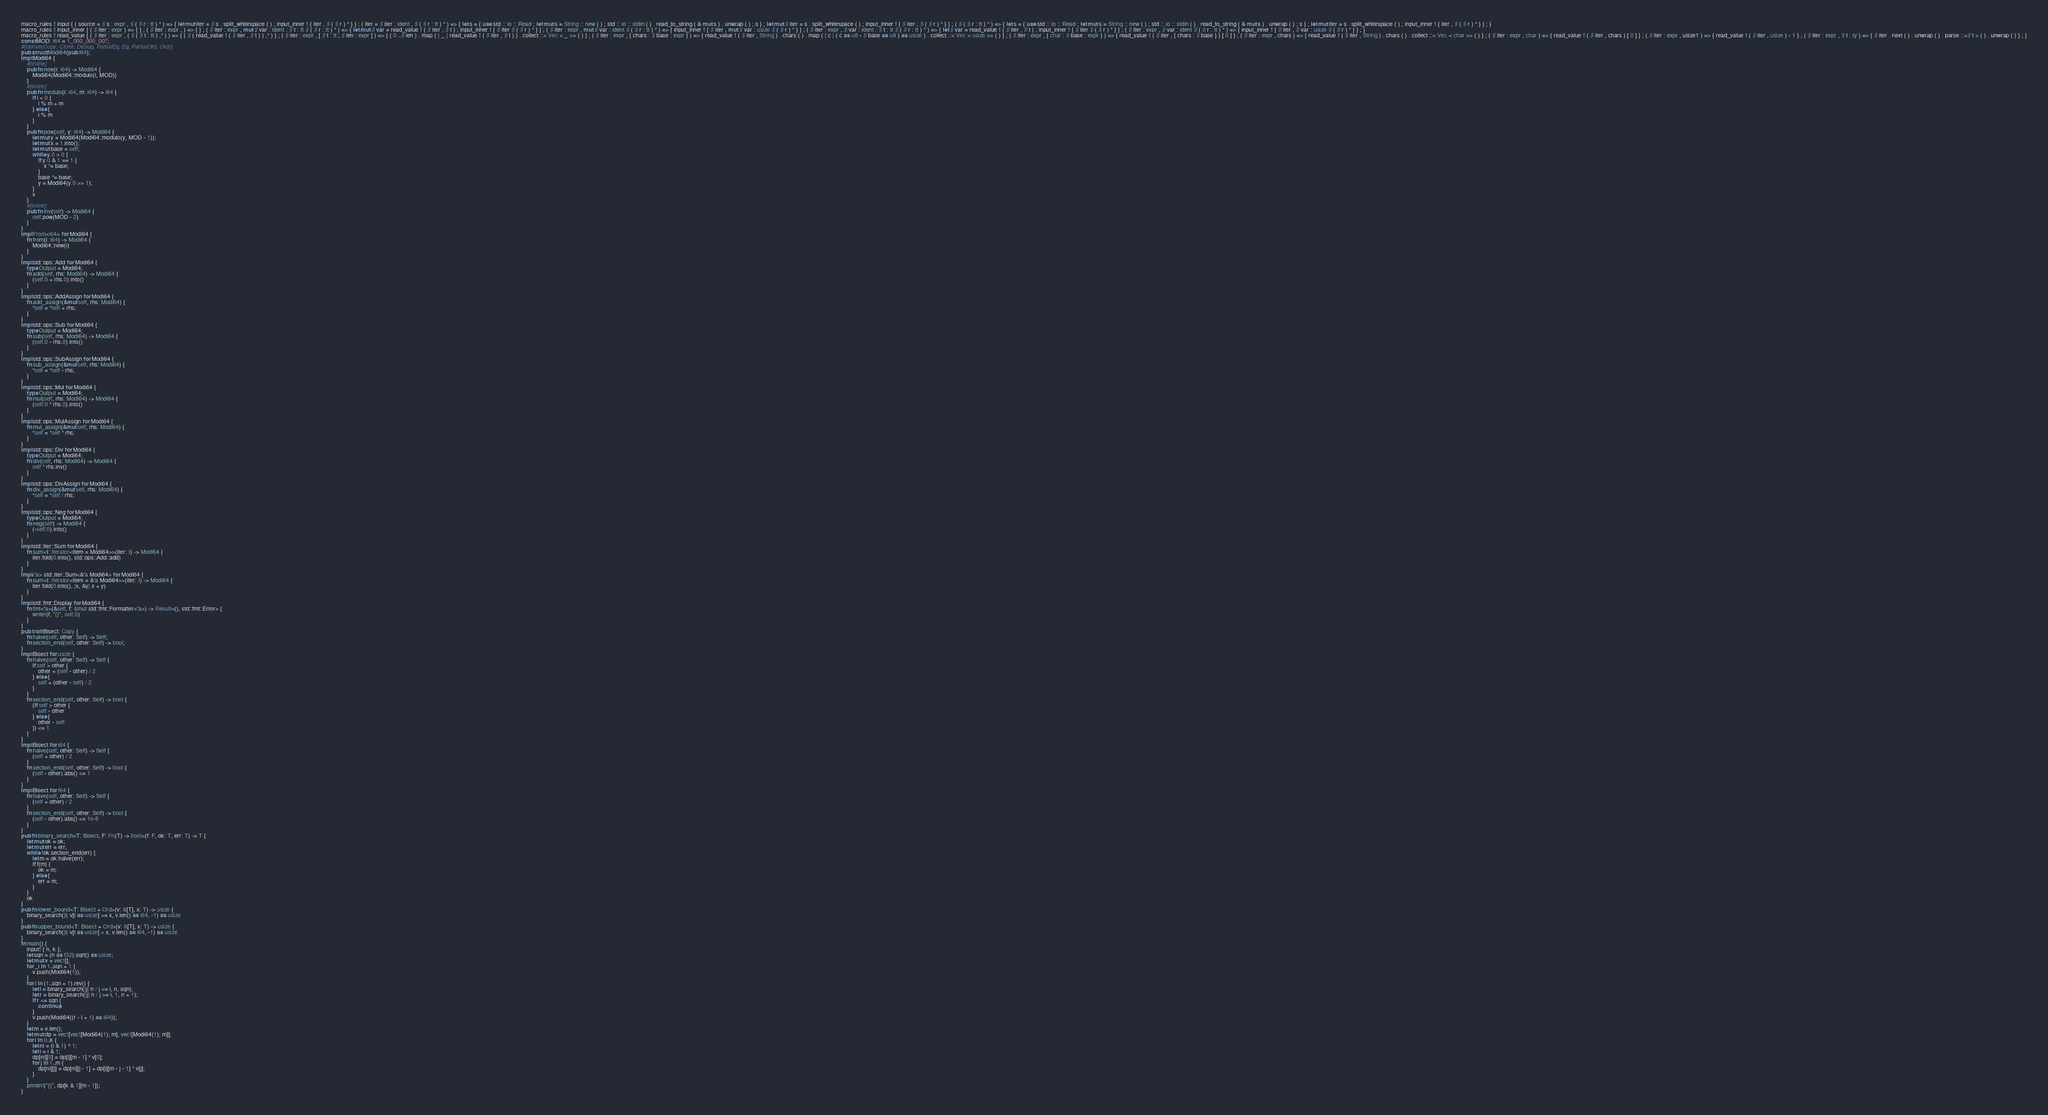Convert code to text. <code><loc_0><loc_0><loc_500><loc_500><_Rust_>macro_rules ! input { ( source = $ s : expr , $ ( $ r : tt ) * ) => { let mut iter = $ s . split_whitespace ( ) ; input_inner ! { iter , $ ( $ r ) * } } ; ( iter = $ iter : ident , $ ( $ r : tt ) * ) => { let s = { use std :: io :: Read ; let mut s = String :: new ( ) ; std :: io :: stdin ( ) . read_to_string ( & mut s ) . unwrap ( ) ; s } ; let mut $ iter = s . split_whitespace ( ) ; input_inner ! { $ iter , $ ( $ r ) * } } ; ( $ ( $ r : tt ) * ) => { let s = { use std :: io :: Read ; let mut s = String :: new ( ) ; std :: io :: stdin ( ) . read_to_string ( & mut s ) . unwrap ( ) ; s } ; let mut iter = s . split_whitespace ( ) ; input_inner ! { iter , $ ( $ r ) * } } ; }
macro_rules ! input_inner { ( $ iter : expr ) => { } ; ( $ iter : expr , ) => { } ; ( $ iter : expr , mut $ var : ident : $ t : tt $ ( $ r : tt ) * ) => { let mut $ var = read_value ! ( $ iter , $ t ) ; input_inner ! { $ iter $ ( $ r ) * } } ; ( $ iter : expr , mut $ var : ident $ ( $ r : tt ) * ) => { input_inner ! { $ iter , mut $ var : usize $ ( $ r ) * } } ; ( $ iter : expr , $ var : ident : $ t : tt $ ( $ r : tt ) * ) => { let $ var = read_value ! ( $ iter , $ t ) ; input_inner ! { $ iter $ ( $ r ) * } } ; ( $ iter : expr , $ var : ident $ ( $ r : tt ) * ) => { input_inner ! { $ iter , $ var : usize $ ( $ r ) * } } ; }
macro_rules ! read_value { ( $ iter : expr , ( $ ( $ t : tt ) ,* ) ) => { ( $ ( read_value ! ( $ iter , $ t ) ) ,* ) } ; ( $ iter : expr , [ $ t : tt ; $ len : expr ] ) => { ( 0 ..$ len ) . map ( | _ | read_value ! ( $ iter , $ t ) ) . collect ::< Vec < _ >> ( ) } ; ( $ iter : expr , { chars : $ base : expr } ) => { read_value ! ( $ iter , String ) . chars ( ) . map ( | c | ( c as u8 - $ base as u8 ) as usize ) . collect ::< Vec < usize >> ( ) } ; ( $ iter : expr , { char : $ base : expr } ) => { read_value ! ( $ iter , { chars : $ base } ) [ 0 ] } ; ( $ iter : expr , chars ) => { read_value ! ( $ iter , String ) . chars ( ) . collect ::< Vec < char >> ( ) } ; ( $ iter : expr , char ) => { read_value ! ( $ iter , chars ) [ 0 ] } ; ( $ iter : expr , usize1 ) => { read_value ! ( $ iter , usize ) - 1 } ; ( $ iter : expr , $ t : ty ) => { $ iter . next ( ) . unwrap ( ) . parse ::<$ t > ( ) . unwrap ( ) } ; }
const MOD: i64 = 1_000_000_007;
#[derive(Copy, Clone, Debug, PartialEq, Eq, PartialOrd, Ord)]
pub struct Modi64(pub i64);
impl Modi64 {
    #[inline]
    pub fn new(i: i64) -> Modi64 {
        Modi64(Modi64::modulo(i, MOD))
    }
    #[inline]
    pub fn modulo(i: i64, m: i64) -> i64 {
        if i < 0 {
            i % m + m
        } else {
            i % m
        }
    }
    pub fn pow(self, y: i64) -> Modi64 {
        let mut y = Modi64(Modi64::modulo(y, MOD - 1));
        let mut x = 1.into();
        let mut base = self;
        while y.0 > 0 {
            if y.0 & 1 == 1 {
                x *= base;
            }
            base *= base;
            y = Modi64(y.0 >> 1);
        }
        x
    }
    #[inline]
    pub fn inv(self) -> Modi64 {
        self.pow(MOD - 2)
    }
}
impl From<i64> for Modi64 {
    fn from(i: i64) -> Modi64 {
        Modi64::new(i)
    }
}
impl std::ops::Add for Modi64 {
    type Output = Modi64;
    fn add(self, rhs: Modi64) -> Modi64 {
        (self.0 + rhs.0).into()
    }
}
impl std::ops::AddAssign for Modi64 {
    fn add_assign(&mut self, rhs: Modi64) {
        *self = *self + rhs;
    }
}
impl std::ops::Sub for Modi64 {
    type Output = Modi64;
    fn sub(self, rhs: Modi64) -> Modi64 {
        (self.0 - rhs.0).into()
    }
}
impl std::ops::SubAssign for Modi64 {
    fn sub_assign(&mut self, rhs: Modi64) {
        *self = *self - rhs;
    }
}
impl std::ops::Mul for Modi64 {
    type Output = Modi64;
    fn mul(self, rhs: Modi64) -> Modi64 {
        (self.0 * rhs.0).into()
    }
}
impl std::ops::MulAssign for Modi64 {
    fn mul_assign(&mut self, rhs: Modi64) {
        *self = *self * rhs;
    }
}
impl std::ops::Div for Modi64 {
    type Output = Modi64;
    fn div(self, rhs: Modi64) -> Modi64 {
        self * rhs.inv()
    }
}
impl std::ops::DivAssign for Modi64 {
    fn div_assign(&mut self, rhs: Modi64) {
        *self = *self / rhs;
    }
}
impl std::ops::Neg for Modi64 {
    type Output = Modi64;
    fn neg(self) -> Modi64 {
        (-self.0).into()
    }
}
impl std::iter::Sum for Modi64 {
    fn sum<I: Iterator<Item = Modi64>>(iter: I) -> Modi64 {
        iter.fold(0.into(), std::ops::Add::add)
    }
}
impl<'a> std::iter::Sum<&'a Modi64> for Modi64 {
    fn sum<I: Iterator<Item = &'a Modi64>>(iter: I) -> Modi64 {
        iter.fold(0.into(), |x, &y| x + y)
    }
}
impl std::fmt::Display for Modi64 {
    fn fmt<'a>(&self, f: &mut std::fmt::Formatter<'a>) -> Result<(), std::fmt::Error> {
        write!(f, "{}", self.0)
    }
}
pub trait Bisect: Copy {
    fn halve(self, other: Self) -> Self;
    fn section_end(self, other: Self) -> bool;
}
impl Bisect for usize {
    fn halve(self, other: Self) -> Self {
        if self > other {
            other + (self - other) / 2
        } else {
            self + (other - self) / 2
        }
    }
    fn section_end(self, other: Self) -> bool {
        (if self > other {
            self - other
        } else {
            other - self
        }) <= 1
    }
}
impl Bisect for i64 {
    fn halve(self, other: Self) -> Self {
        (self + other) / 2
    }
    fn section_end(self, other: Self) -> bool {
        (self - other).abs() <= 1
    }
}
impl Bisect for f64 {
    fn halve(self, other: Self) -> Self {
        (self + other) / 2.
    }
    fn section_end(self, other: Self) -> bool {
        (self - other).abs() <= 1e-8
    }
}
pub fn binary_search<T: Bisect, F: Fn(T) -> bool>(f: F, ok: T, err: T) -> T {
    let mut ok = ok;
    let mut err = err;
    while !ok.section_end(err) {
        let m = ok.halve(err);
        if f(m) {
            ok = m;
        } else {
            err = m;
        }
    }
    ok
}
pub fn lower_bound<T: Bisect + Ord>(v: &[T], x: T) -> usize {
    binary_search(|i| v[i as usize] >= x, v.len() as i64, -1) as usize
}
pub fn upper_bound<T: Bisect + Ord>(v: &[T], x: T) -> usize {
    binary_search(|i| v[i as usize] > x, v.len() as i64, -1) as usize
}
fn main() {
    input! { n, k };
    let sqn = (n as f32).sqrt() as usize;
    let mut v = vec![];
    for _i in 1..sqn + 1 {
        v.push(Modi64(1));
    }
    for i in (1..sqn + 1).rev() {
        let l = binary_search(|j| n / j <= i, n, sqn);
        let r = binary_search(|j| n / j >= i, 1, n + 1);
        if r <= sqn {
            continue;
        }
        v.push(Modi64((r - l + 1) as i64));
    }
    let m = v.len();
    let mut dp = vec![vec![Modi64(1); m], vec![Modi64(1); m]];
    for i in 0..k {
        let ni = (i & 1) ^ 1;
        let i = i & 1;
        dp[ni][0] = dp[i][m - 1] * v[0];
        for j in 1..m {
            dp[ni][j] = dp[ni][j - 1] + dp[i][m - j - 1] * v[j];
        }
    }
    println!("{}", dp[k & 1][m - 1]);
}
</code> 